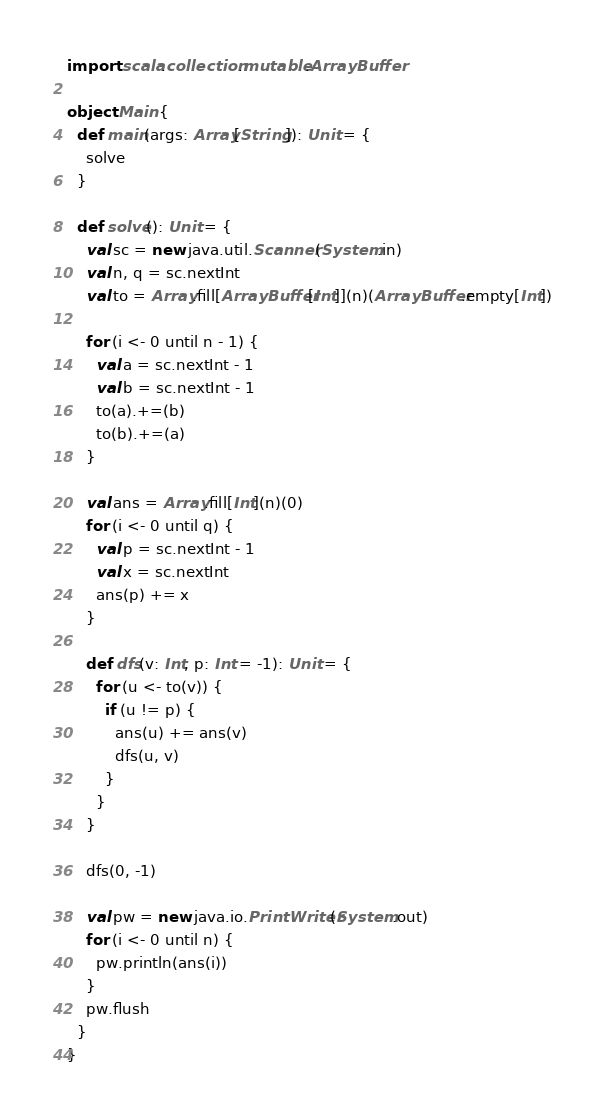Convert code to text. <code><loc_0><loc_0><loc_500><loc_500><_Scala_>import scala.collection.mutable.ArrayBuffer

object Main {
  def main(args: Array[String]): Unit = {
    solve
  }

  def solve(): Unit = {
    val sc = new java.util.Scanner(System.in)
    val n, q = sc.nextInt
    val to = Array.fill[ArrayBuffer[Int]](n)(ArrayBuffer.empty[Int])

    for (i <- 0 until n - 1) {
      val a = sc.nextInt - 1
      val b = sc.nextInt - 1
      to(a).+=(b)
      to(b).+=(a)
    }

    val ans = Array.fill[Int](n)(0)
    for (i <- 0 until q) {
      val p = sc.nextInt - 1
      val x = sc.nextInt
      ans(p) += x
    }

    def dfs(v: Int, p: Int = -1): Unit = {
      for (u <- to(v)) {
        if (u != p) {
          ans(u) += ans(v)
          dfs(u, v)
        }
      }
    }

    dfs(0, -1)

    val pw = new java.io.PrintWriter(System.out)
    for (i <- 0 until n) {
      pw.println(ans(i))
    }
    pw.flush
  }
}
</code> 